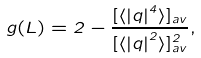Convert formula to latex. <formula><loc_0><loc_0><loc_500><loc_500>g ( L ) = 2 - \frac { [ \langle \left | q \right | ^ { 4 } \rangle ] _ { a v } } { [ \langle \left | q \right | ^ { 2 } \rangle ] _ { a v } ^ { 2 } } ,</formula> 